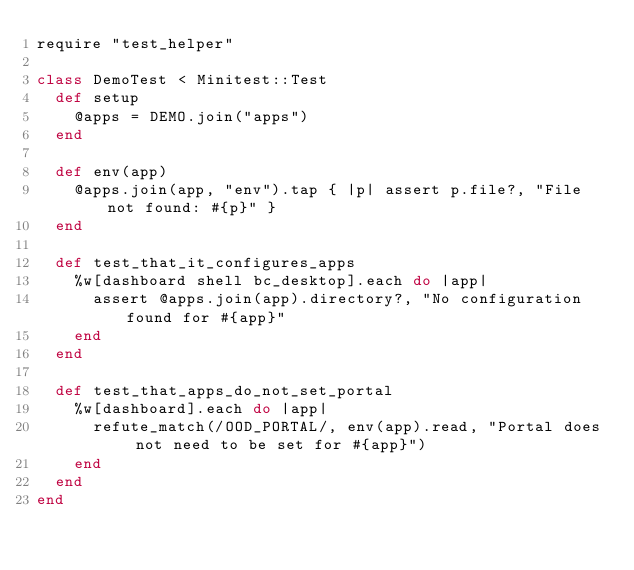<code> <loc_0><loc_0><loc_500><loc_500><_Ruby_>require "test_helper"

class DemoTest < Minitest::Test
  def setup
    @apps = DEMO.join("apps")
  end

  def env(app)
    @apps.join(app, "env").tap { |p| assert p.file?, "File not found: #{p}" }
  end

  def test_that_it_configures_apps
    %w[dashboard shell bc_desktop].each do |app|
      assert @apps.join(app).directory?, "No configuration found for #{app}"
    end
  end

  def test_that_apps_do_not_set_portal
    %w[dashboard].each do |app|
      refute_match(/OOD_PORTAL/, env(app).read, "Portal does not need to be set for #{app}")
    end
  end
end
</code> 